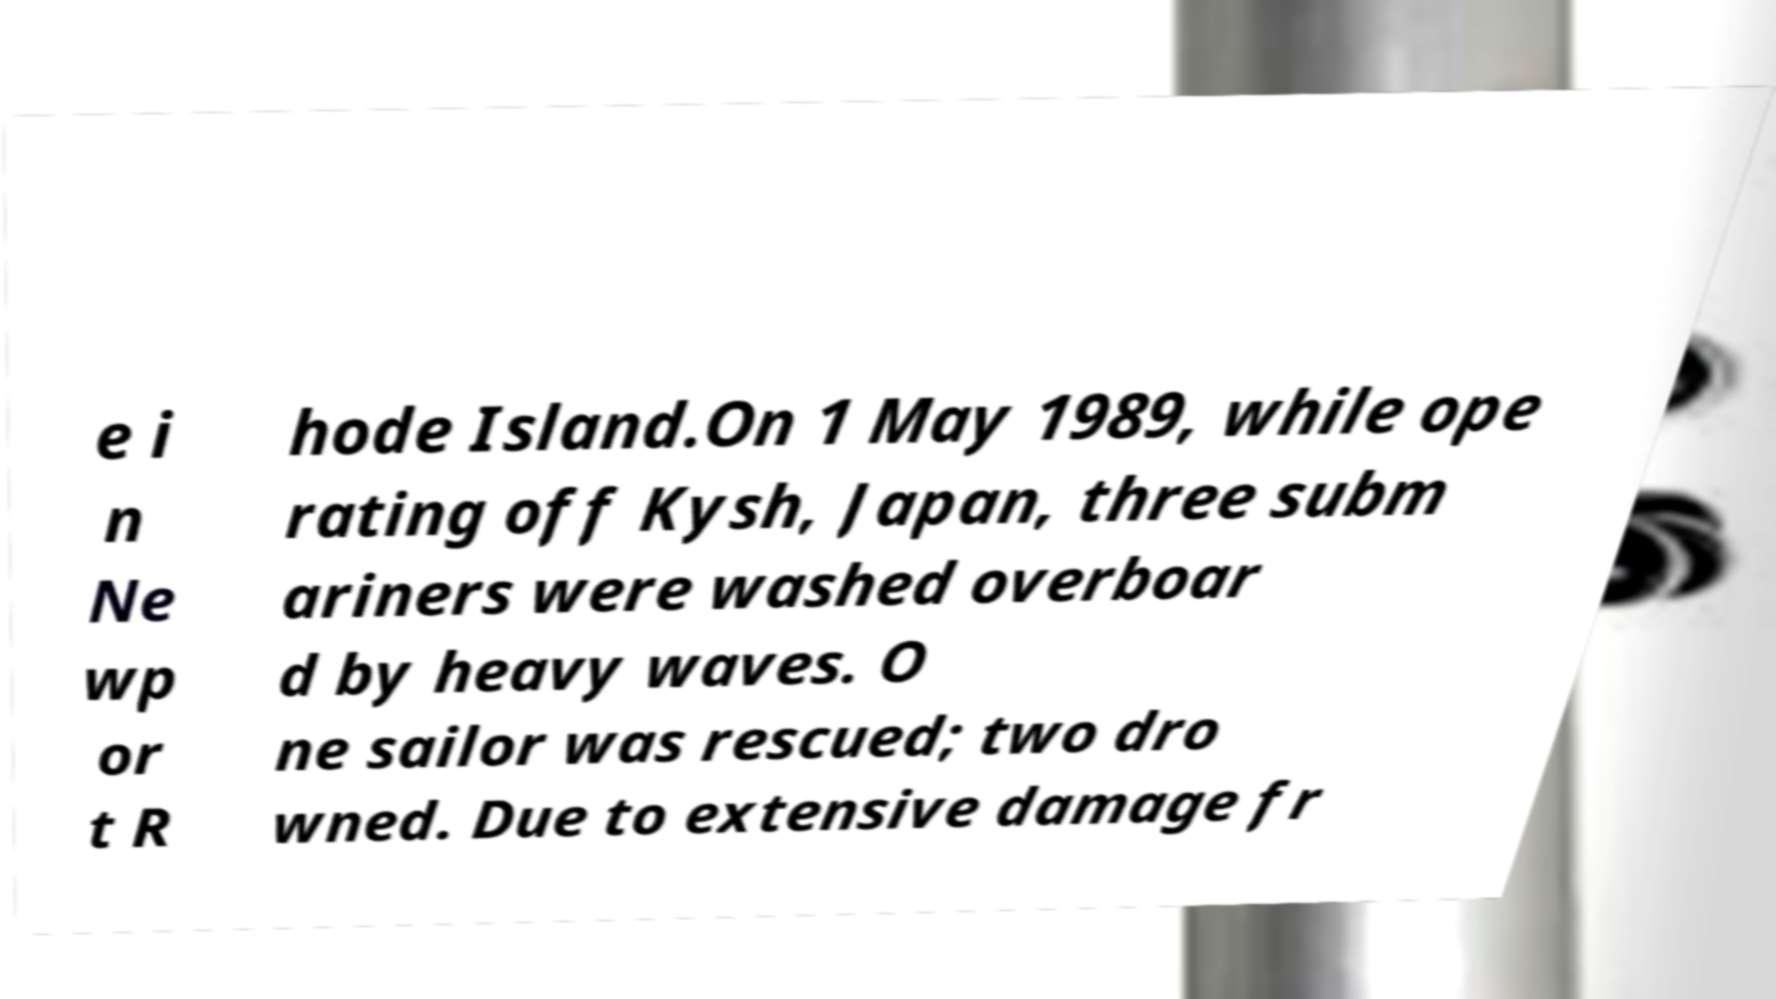Can you read and provide the text displayed in the image?This photo seems to have some interesting text. Can you extract and type it out for me? e i n Ne wp or t R hode Island.On 1 May 1989, while ope rating off Kysh, Japan, three subm ariners were washed overboar d by heavy waves. O ne sailor was rescued; two dro wned. Due to extensive damage fr 